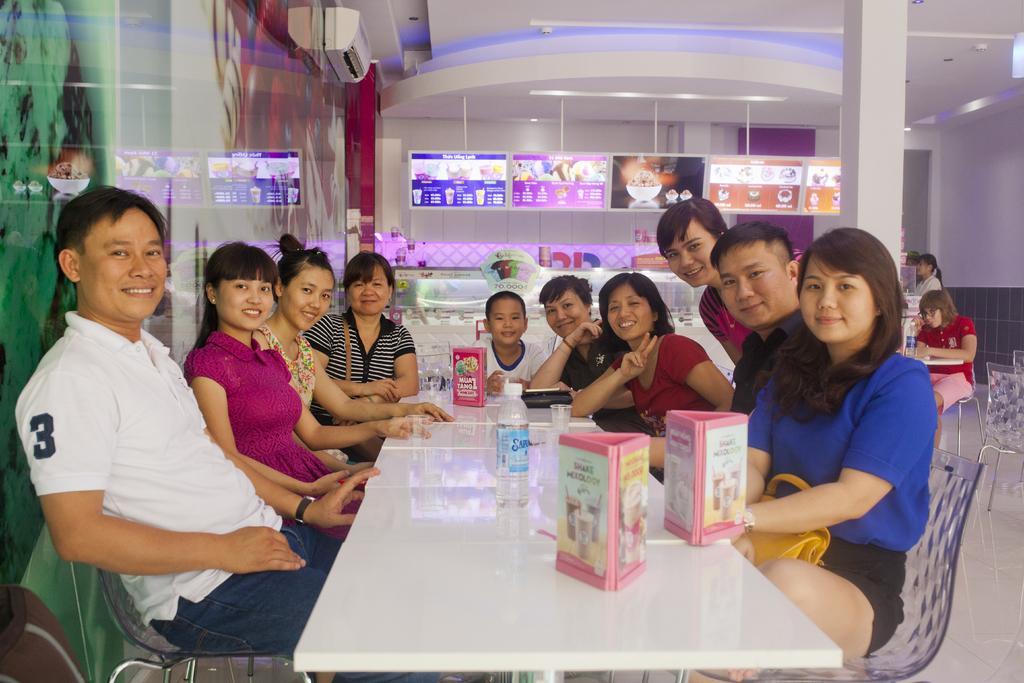Describe this image in one or two sentences. In this picture we can see some people are sitting on the chairs, in front we can see the table on which few objects are placed, behind we can see few people. 